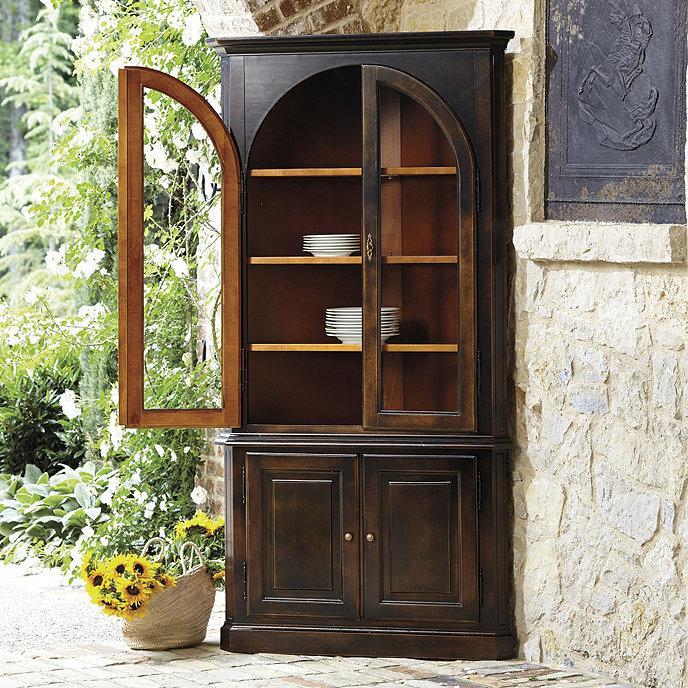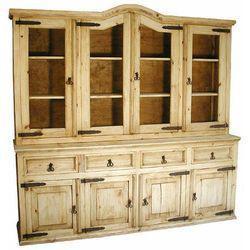The first image is the image on the left, the second image is the image on the right. For the images displayed, is the sentence "Both of the cabinets depicted have flat tops and some type of feet." factually correct? Answer yes or no. No. 